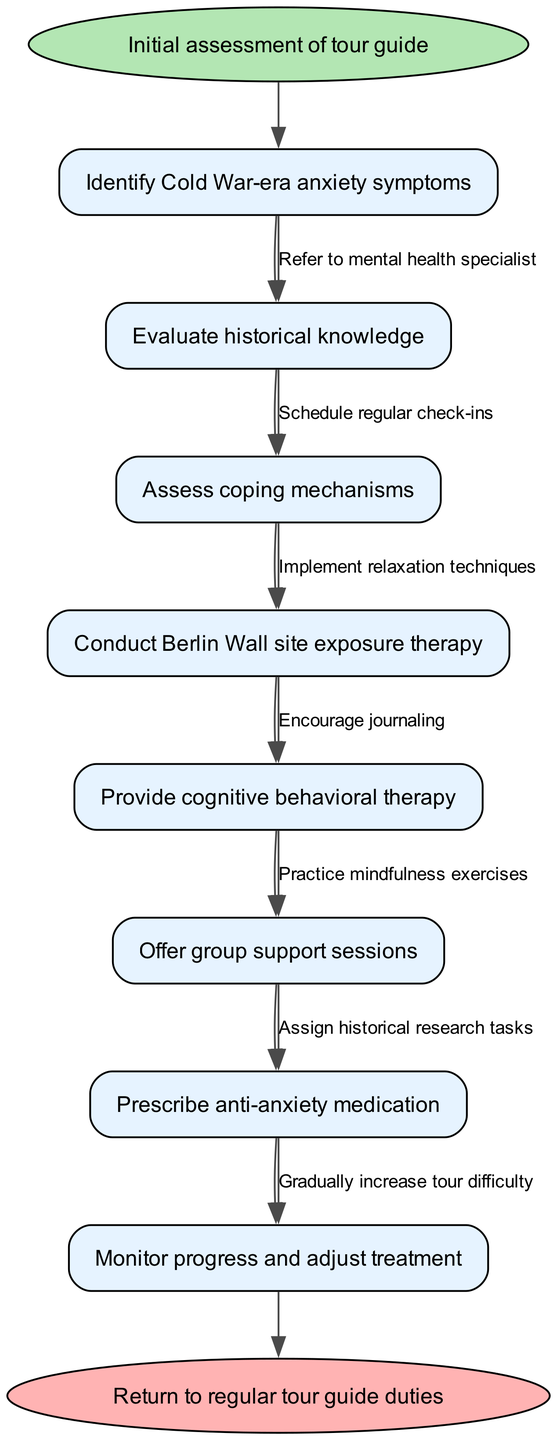What is the first step in the clinical pathway? The diagram starts with the "Initial assessment of tour guide" node, indicating the first step in the clinical pathway.
Answer: Initial assessment of tour guide How many nodes are present in the clinical pathway? The diagram lists a total of 8 nodes, including the start and end nodes, when counting all the nodes mentioned in the nodes section, including the initial assessment and final return.
Answer: 8 What type of therapy is provided after assessing coping mechanisms? Following the "Assess coping mechanisms" node, the next node provided is "Provide cognitive behavioral therapy," indicating the type of therapy offered.
Answer: Provide cognitive behavioral therapy What is the relationship between group support sessions and anti-anxiety medication? The edges in the diagram connect "Offer group support sessions" and "Prescribe anti-anxiety medication," suggesting that these steps can be part of the clinical pathway but are independent of each other.
Answer: Independent What is the final outcome of the clinical pathway? The diagram concludes with the "Return to regular tour guide duties" node, representing the final outcome of the pathway after all clinical interventions.
Answer: Return to regular tour guide duties Which node is directly connected to the "Conduct Berlin Wall site exposure therapy"? The edge connects "Conduct Berlin Wall site exposure therapy" to the next node, "Provide cognitive behavioral therapy," indicating that it follows that specific step in the pathway.
Answer: Provide cognitive behavioral therapy What technique is encouraged alongside offering group support sessions? The edge from "Offer group support sessions" also connects to implementing "relaxation techniques," indicating another intervention that is encouraged in this context.
Answer: Implement relaxation techniques How many edges are used to connect the nodes in this clinical pathway? Based on the edges listed, there are 7 edges defined that link each node in the pathway together, showing the flow of treatment.
Answer: 7 